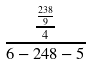<formula> <loc_0><loc_0><loc_500><loc_500>\frac { \frac { \frac { 2 3 8 } { 9 } } { 4 } } { 6 - 2 4 8 - 5 }</formula> 